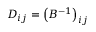<formula> <loc_0><loc_0><loc_500><loc_500>D _ { i j } = { \left ( B ^ { - 1 } \right ) } _ { i j }</formula> 